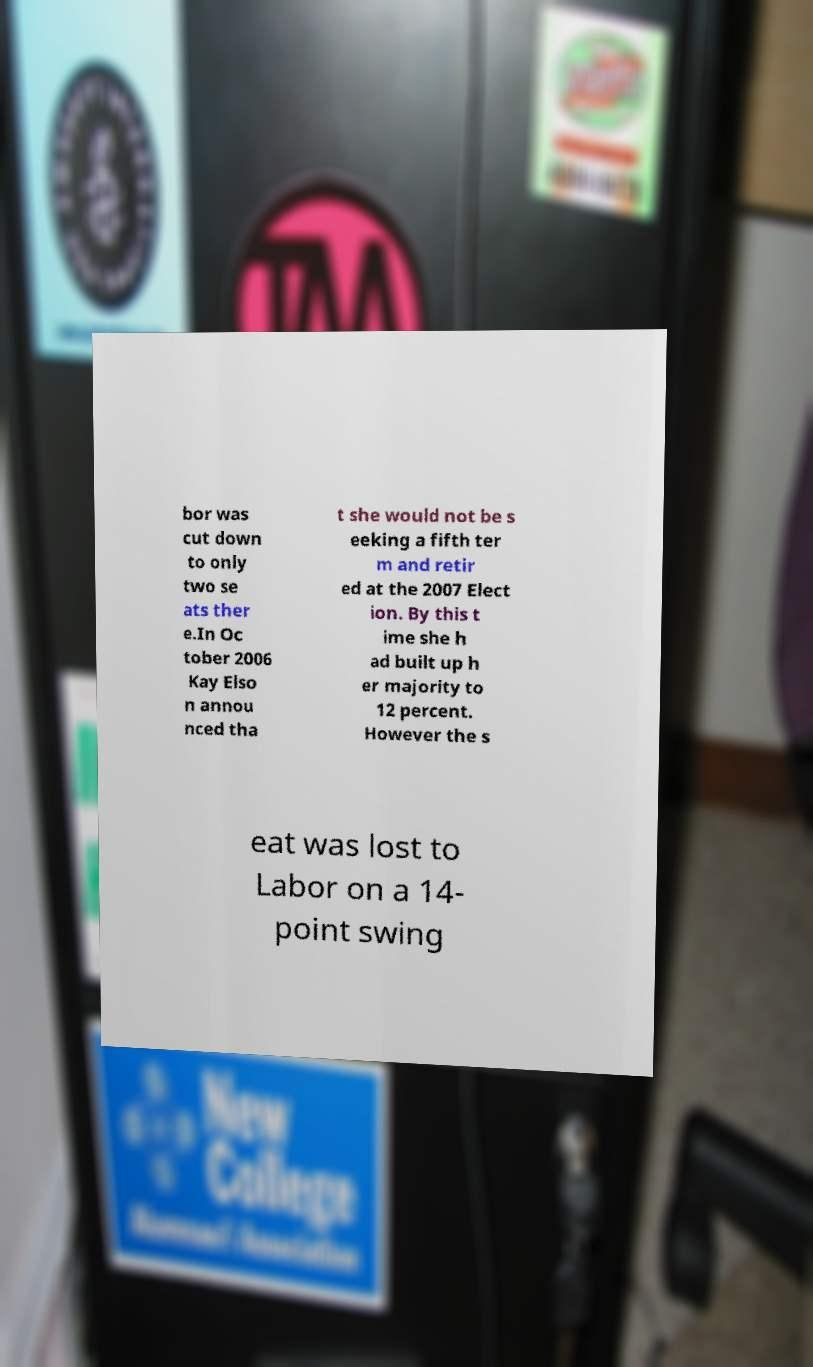Could you assist in decoding the text presented in this image and type it out clearly? bor was cut down to only two se ats ther e.In Oc tober 2006 Kay Elso n annou nced tha t she would not be s eeking a fifth ter m and retir ed at the 2007 Elect ion. By this t ime she h ad built up h er majority to 12 percent. However the s eat was lost to Labor on a 14- point swing 